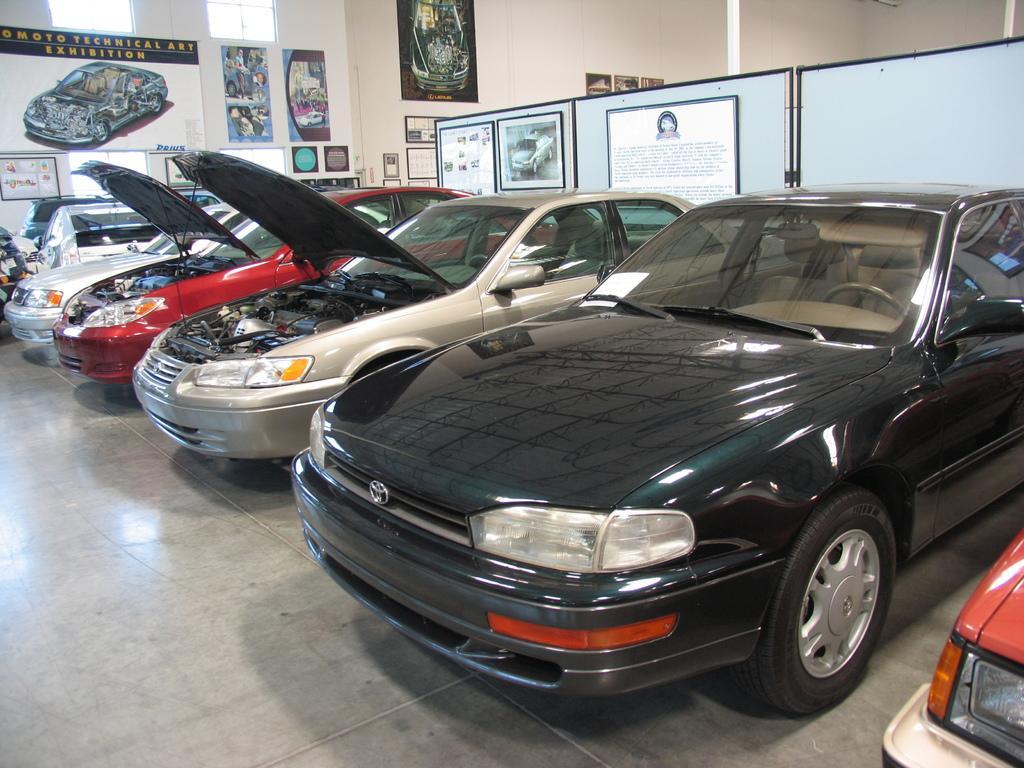Describe this image in one or two sentences. In this image I can see vehicles on the floor. In the background I can see a wall, posters, boards, photo frames, wall paintings and so on. This image is taken may be in a hall. 